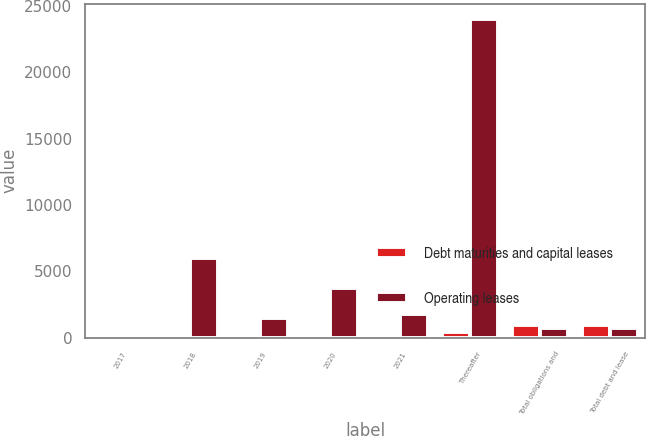Convert chart. <chart><loc_0><loc_0><loc_500><loc_500><stacked_bar_chart><ecel><fcel>2017<fcel>2018<fcel>2019<fcel>2020<fcel>2021<fcel>Thereafter<fcel>Total obligations and<fcel>Total debt and lease<nl><fcel>Debt maturities and capital leases<fcel>131<fcel>116<fcel>106<fcel>95<fcel>77<fcel>449<fcel>974<fcel>974<nl><fcel>Operating leases<fcel>25<fcel>6023<fcel>1480<fcel>3760<fcel>1802<fcel>23987<fcel>711.5<fcel>711.5<nl></chart> 